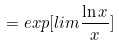Convert formula to latex. <formula><loc_0><loc_0><loc_500><loc_500>= e x p [ l i m \frac { \ln x } { x } ]</formula> 